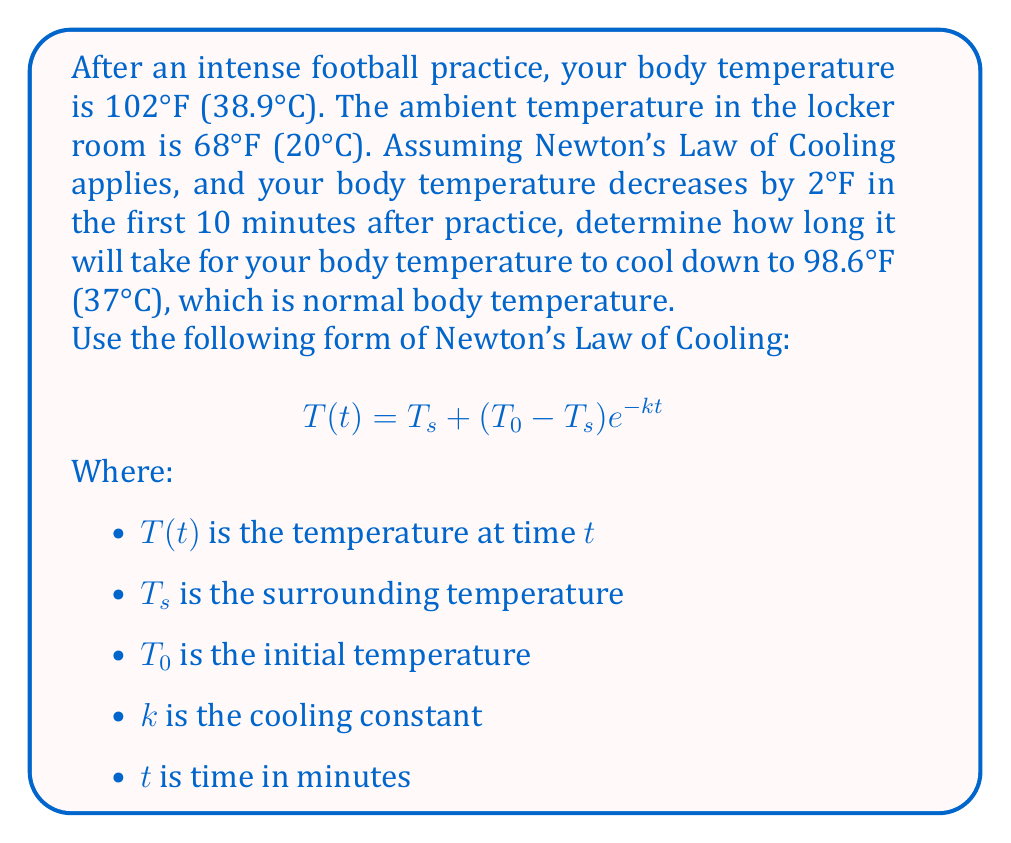Solve this math problem. Let's solve this step-by-step:

1) First, we need to find the cooling constant $k$. We can use the given information that the temperature decreases by 2°F in 10 minutes.

2) We know:
   $T_0 = 102°F$
   $T_s = 68°F$
   $T(10) = 100°F$ (after 10 minutes, temperature dropped by 2°F)

3) Plug these into the equation:
   $$100 = 68 + (102 - 68)e^{-10k}$$

4) Simplify:
   $$32 = 34e^{-10k}$$

5) Divide both sides by 34:
   $$\frac{32}{34} = e^{-10k}$$

6) Take natural log of both sides:
   $$\ln(\frac{32}{34}) = -10k$$

7) Solve for $k$:
   $$k = -\frac{1}{10}\ln(\frac{32}{34}) \approx 0.00614$$

8) Now that we have $k$, we can find the time it takes to reach 98.6°F. Use the original equation:
   $$98.6 = 68 + (102 - 68)e^{-0.00614t}$$

9) Simplify:
   $$30.6 = 34e^{-0.00614t}$$

10) Divide both sides by 34:
    $$\frac{30.6}{34} = e^{-0.00614t}$$

11) Take natural log of both sides:
    $$\ln(\frac{30.6}{34}) = -0.00614t$$

12) Solve for $t$:
    $$t = -\frac{1}{0.00614}\ln(\frac{30.6}{34}) \approx 53.4$$

Therefore, it will take approximately 53.4 minutes for your body temperature to cool down to normal.
Answer: 53.4 minutes 